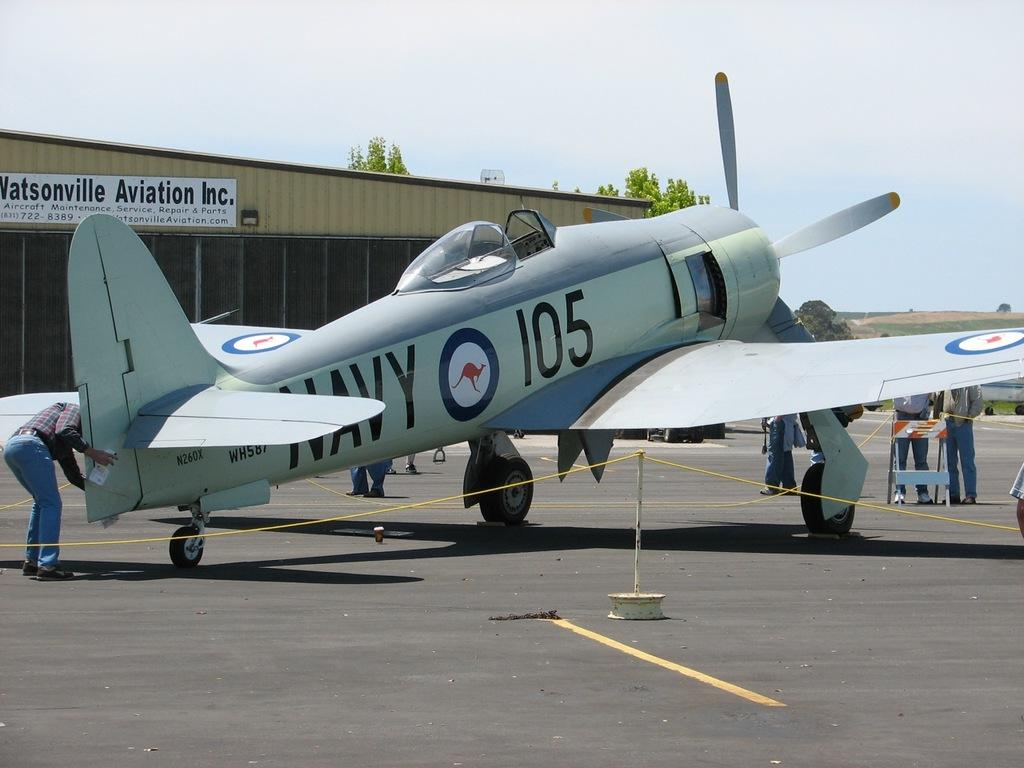<image>
Render a clear and concise summary of the photo. A small light green Navy airplane parked at Watsonville Aviation Inc. 